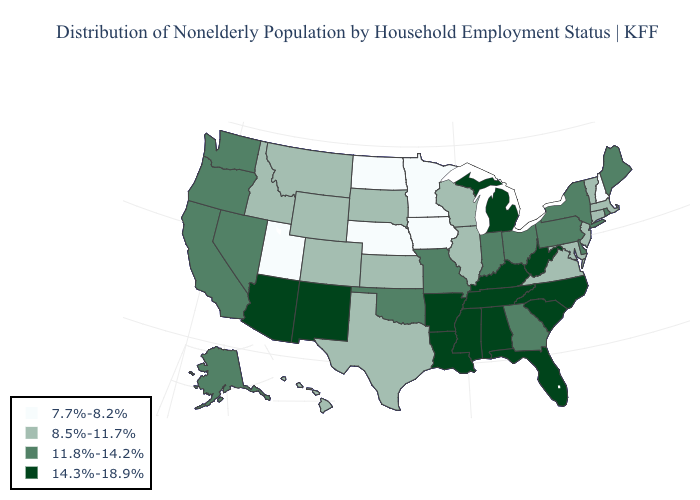How many symbols are there in the legend?
Quick response, please. 4. Is the legend a continuous bar?
Give a very brief answer. No. Among the states that border Missouri , does Oklahoma have the highest value?
Write a very short answer. No. Does the map have missing data?
Concise answer only. No. Which states have the lowest value in the USA?
Keep it brief. Iowa, Minnesota, Nebraska, New Hampshire, North Dakota, Utah. Which states have the highest value in the USA?
Short answer required. Alabama, Arizona, Arkansas, Florida, Kentucky, Louisiana, Michigan, Mississippi, New Mexico, North Carolina, South Carolina, Tennessee, West Virginia. Name the states that have a value in the range 14.3%-18.9%?
Be succinct. Alabama, Arizona, Arkansas, Florida, Kentucky, Louisiana, Michigan, Mississippi, New Mexico, North Carolina, South Carolina, Tennessee, West Virginia. What is the value of Louisiana?
Answer briefly. 14.3%-18.9%. Name the states that have a value in the range 11.8%-14.2%?
Concise answer only. Alaska, California, Delaware, Georgia, Indiana, Maine, Missouri, Nevada, New York, Ohio, Oklahoma, Oregon, Pennsylvania, Rhode Island, Washington. Does Iowa have the lowest value in the USA?
Answer briefly. Yes. Which states have the highest value in the USA?
Be succinct. Alabama, Arizona, Arkansas, Florida, Kentucky, Louisiana, Michigan, Mississippi, New Mexico, North Carolina, South Carolina, Tennessee, West Virginia. Among the states that border Louisiana , does Mississippi have the lowest value?
Quick response, please. No. Name the states that have a value in the range 11.8%-14.2%?
Be succinct. Alaska, California, Delaware, Georgia, Indiana, Maine, Missouri, Nevada, New York, Ohio, Oklahoma, Oregon, Pennsylvania, Rhode Island, Washington. Which states have the lowest value in the South?
Answer briefly. Maryland, Texas, Virginia. Name the states that have a value in the range 14.3%-18.9%?
Short answer required. Alabama, Arizona, Arkansas, Florida, Kentucky, Louisiana, Michigan, Mississippi, New Mexico, North Carolina, South Carolina, Tennessee, West Virginia. 